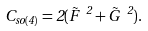Convert formula to latex. <formula><loc_0><loc_0><loc_500><loc_500>C _ { s o ( 4 ) } = 2 ( \vec { F } \ ^ { 2 } + \vec { G } \ ^ { 2 } ) .</formula> 